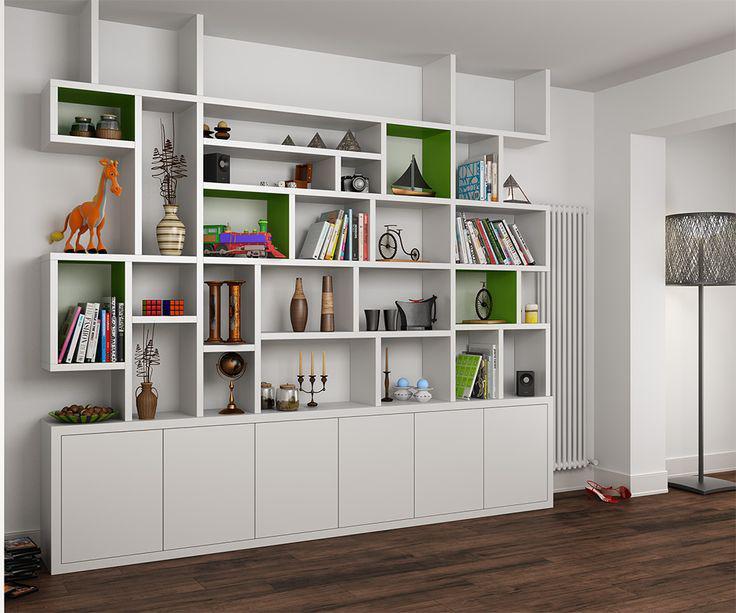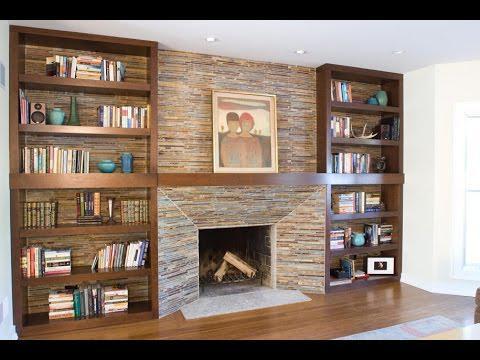The first image is the image on the left, the second image is the image on the right. For the images displayed, is the sentence "The left image shows an all white bookcase with an open back." factually correct? Answer yes or no. Yes. 